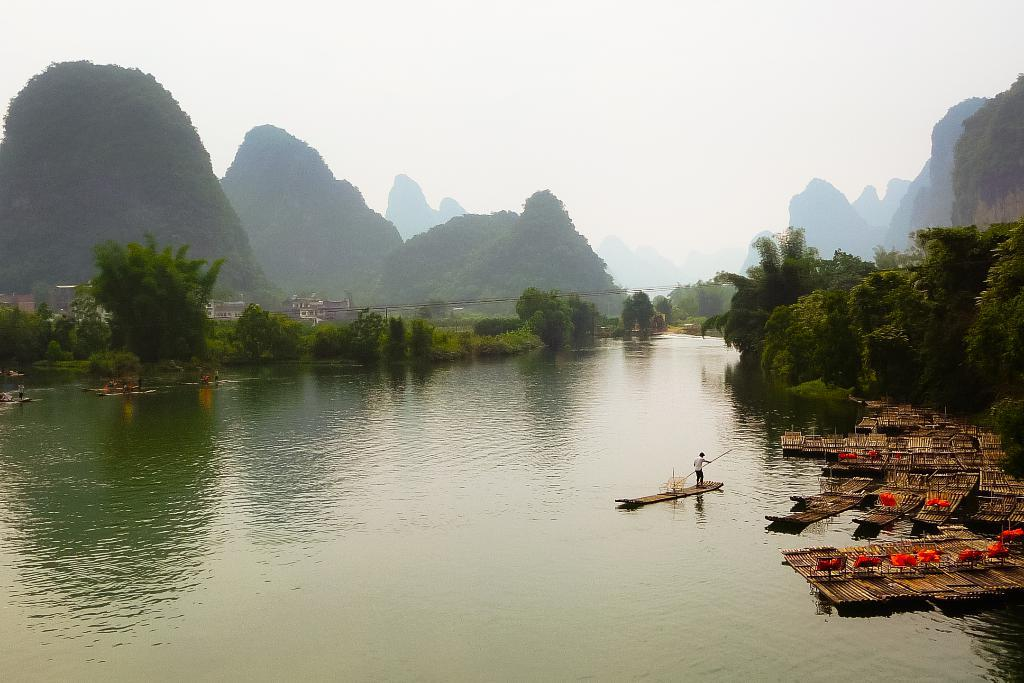What is the main subject in the center of the image? There is water in the center of the image. What else can be seen in the image besides the water? There are boats, trees on both sides, mountains, houses, and the sky visible in the background of the image. What type of beam is holding up the prison in the image? There is no prison present in the image, so there is no beam to discuss. 